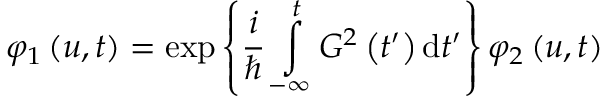<formula> <loc_0><loc_0><loc_500><loc_500>\varphi _ { 1 } \left ( u , t \right ) = \exp \left \{ \frac { i } { } \int o p _ { - \infty } ^ { t } G ^ { 2 } \left ( t ^ { \prime } \right ) d t ^ { \prime } \right \} \varphi _ { 2 } \left ( u , t \right )</formula> 